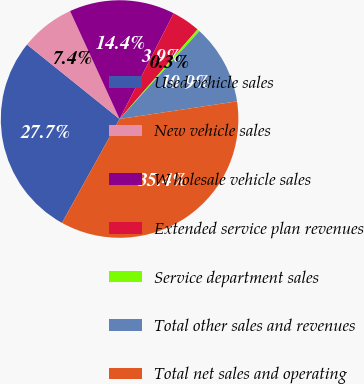Convert chart to OTSL. <chart><loc_0><loc_0><loc_500><loc_500><pie_chart><fcel>Used vehicle sales<fcel>New vehicle sales<fcel>W holesale vehicle sales<fcel>Extended service plan revenues<fcel>Service department sales<fcel>Total other sales and revenues<fcel>Total net sales and operating<nl><fcel>27.73%<fcel>7.37%<fcel>14.38%<fcel>3.86%<fcel>0.35%<fcel>10.88%<fcel>35.44%<nl></chart> 